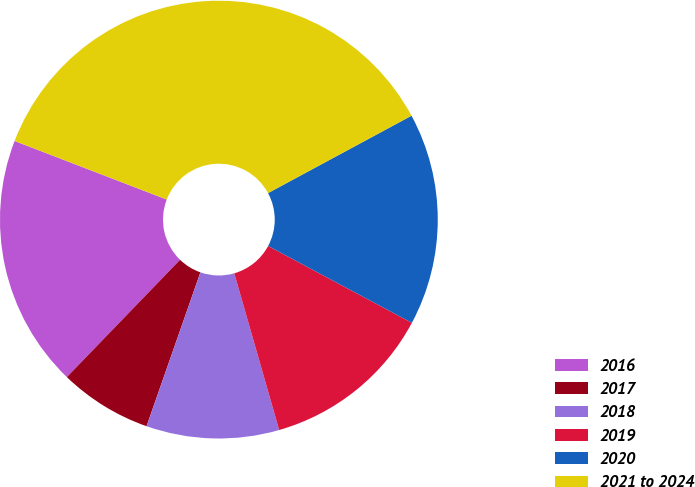Convert chart. <chart><loc_0><loc_0><loc_500><loc_500><pie_chart><fcel>2016<fcel>2017<fcel>2018<fcel>2019<fcel>2020<fcel>2021 to 2024<nl><fcel>18.63%<fcel>6.86%<fcel>9.8%<fcel>12.74%<fcel>15.69%<fcel>36.28%<nl></chart> 